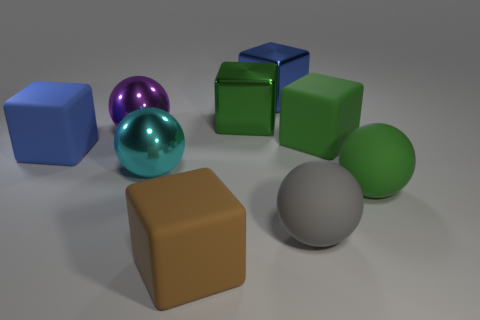How does the lighting in the image influence the appearance of the objects? The lighting in the image is soft and diffused, casting gentle shadows and highlights that give the objects dimensionality. It creates reflections on the metallic spheres, adding to the perception of their curvature and material properties. Which object seems to be the closest to the source of light? The green metallic sphere appears to be closest to the light source based on the brightness and size of its highlight, along with the softer shadow it casts compared to the others. 